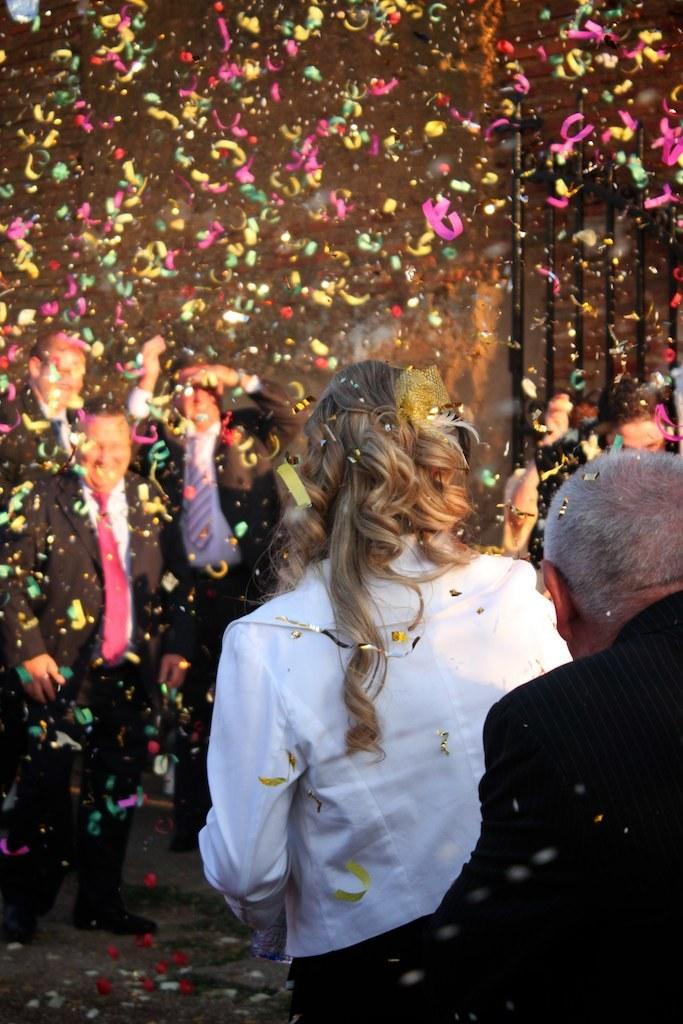What is happening in the image involving people? There are people standing in the image. What is in the air in the image? There are colorful papers in the air. What can be seen in the background of the image? There are black color poles in the background of the image. Can you see any goats or crates in the image? No, there are no goats or crates present in the image. Is this a family gathering, given the presence of people in the image? The image does not provide enough information to determine if it is a family gathering or not. 